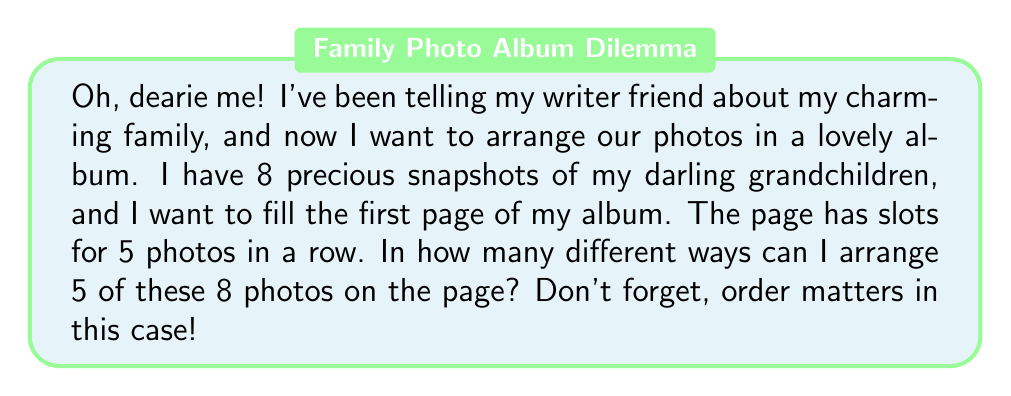Can you answer this question? Let's approach this step-by-step, shall we?

1) First, we need to recognize that this is a permutation problem. We're selecting 5 photos out of 8 and arranging them in a specific order.

2) The formula for permutations is:

   $$P(n,r) = \frac{n!}{(n-r)!}$$

   Where $n$ is the total number of items to choose from, and $r$ is the number of items being arranged.

3) In this case, $n = 8$ (total number of photos) and $r = 5$ (number of photos we're arranging).

4) Let's substitute these values into our formula:

   $$P(8,5) = \frac{8!}{(8-5)!} = \frac{8!}{3!}$$

5) Now, let's calculate this:
   
   $$\frac{8!}{3!} = \frac{8 \times 7 \times 6 \times 5 \times 4 \times 3!}{3!}$$

6) The $3!$ cancels out in the numerator and denominator:

   $$8 \times 7 \times 6 \times 5 \times 4 = 6720$$

Therefore, there are 6720 different ways to arrange 5 photos out of 8 on the page.
Answer: 6720 ways 